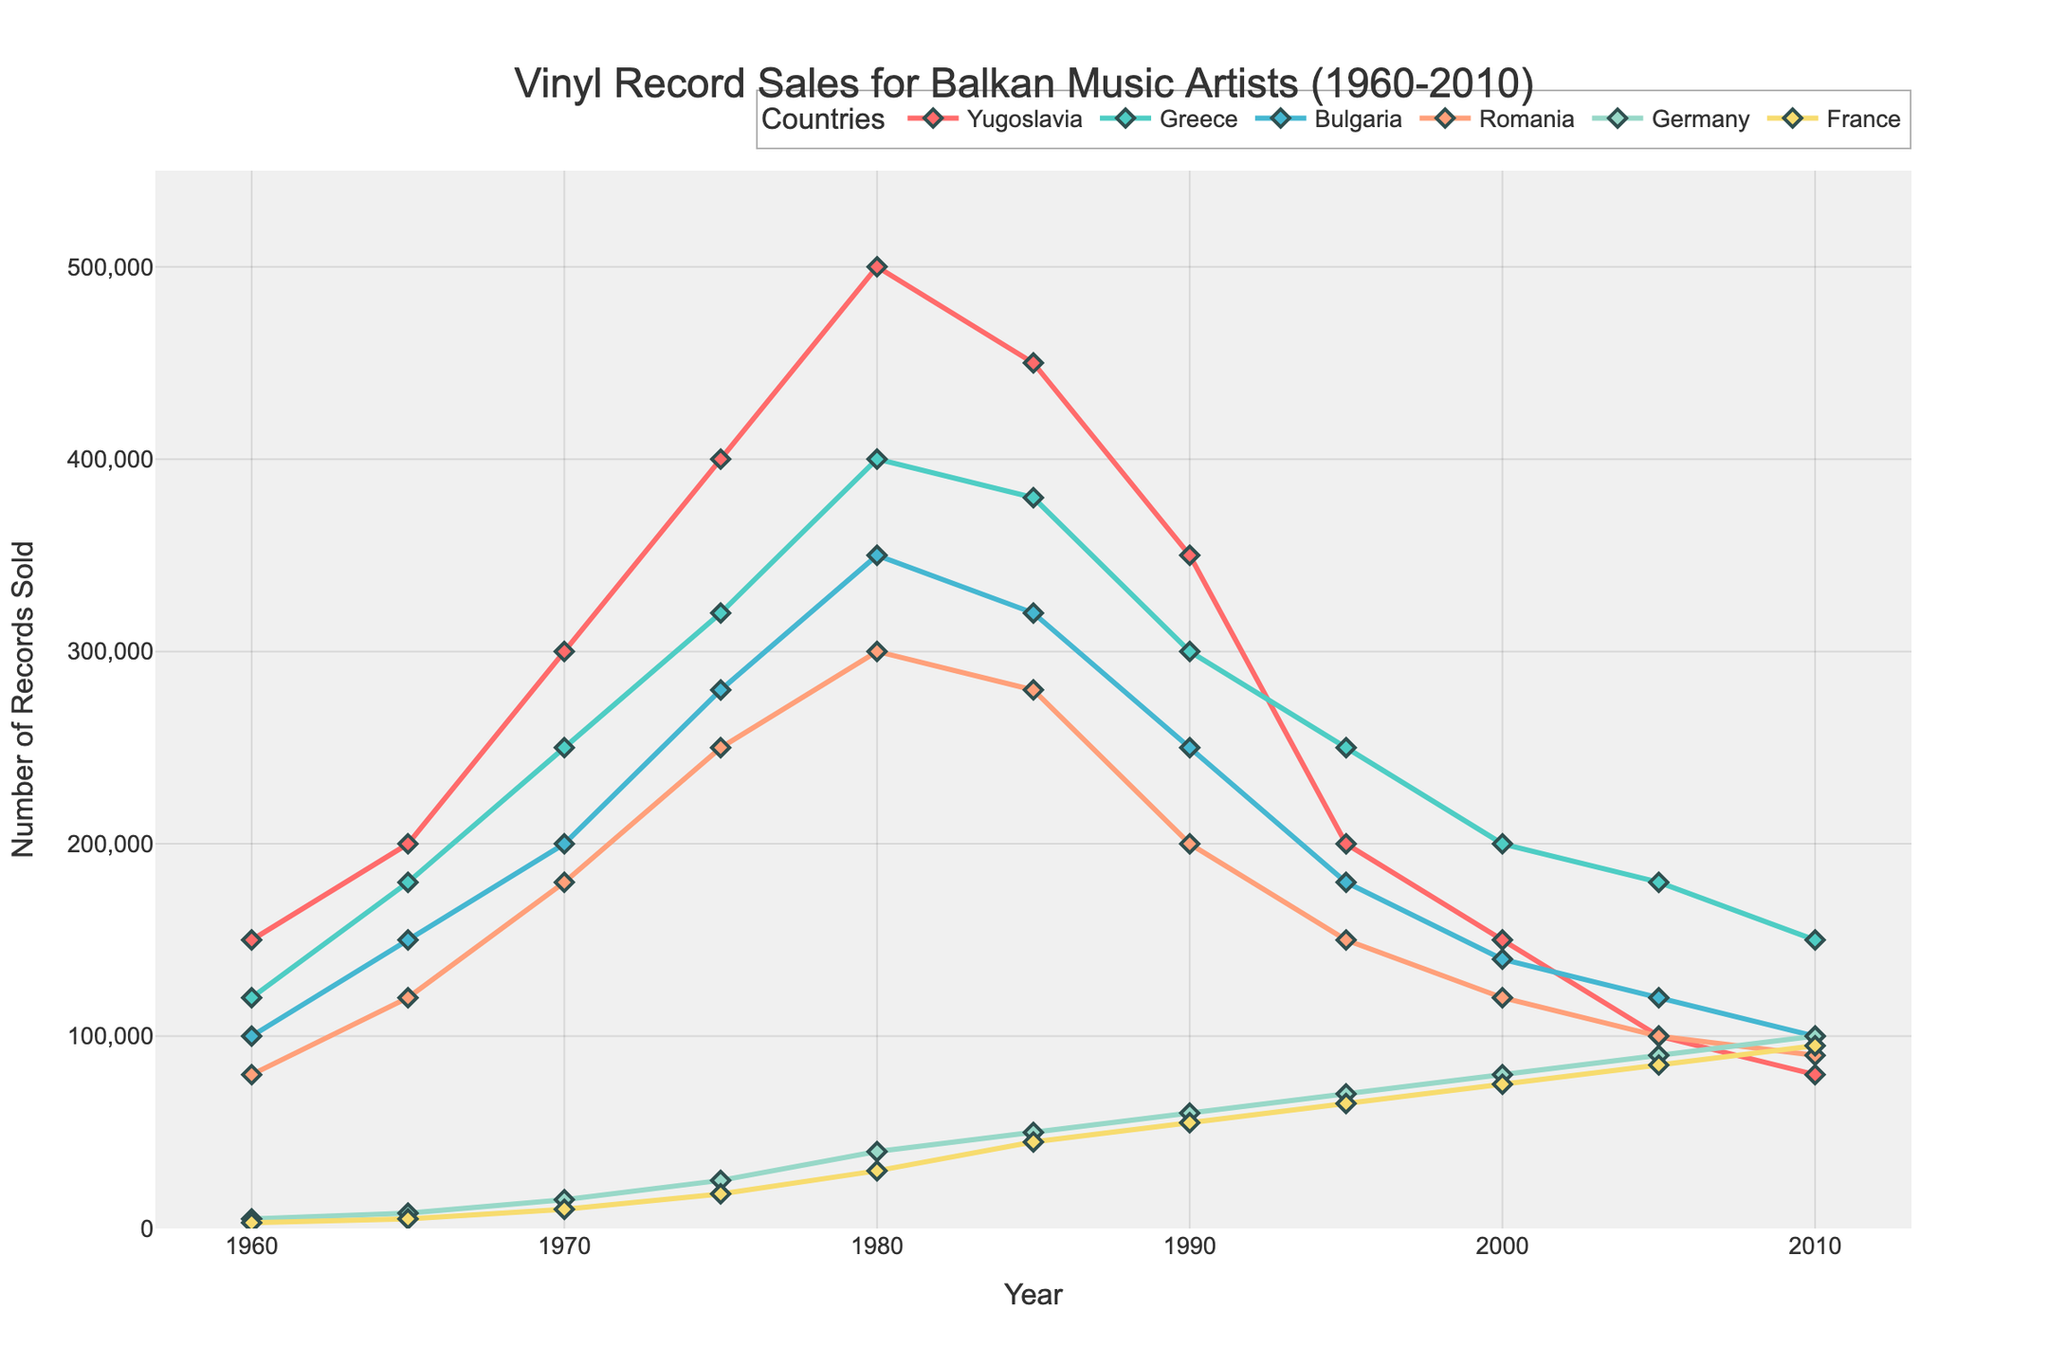What is the trend of vinyl record sales for Yugoslavia from 1960 to 2010? Yugoslavia's vinyl record sales show an initially increasing trend from 1960 (150,000) to 1980 (500,000), then a decline to 2010 (80,000).
Answer: Increasing then decreasing Which country had the highest vinyl record sales in 1980? In 1980, the highest record sales among the countries listed was in Yugoslavia with 500,000 records sold.
Answer: Yugoslavia How did the record sales in France change over the years? The record sales in France gradually increased from 3,000 in 1960 to 95,000 in 2010, showing a general upward trend.
Answer: Increased Which two countries had the most similar record sales in 2010? In 2010, Germany and France had similar record sales with 100,000 and 95,000 records sold, respectively.
Answer: Germany and France What is the average vinyl record sales in Romania from 1960 to 2010? The sales in Romania from 1960 to 2010 (80,000, 120,000, 180,000, 250,000, 300,000, 280,000, 200,000, 150,000, 120,000, 100,000, 90,000) sum to 1,870,000. There are 11 values, so the average is 1,870,000 / 11 ≈ 170,000.
Answer: 170,000 Which country's vinyl record sales decreased the most between 1980 and 1990? Yugoslavia's sales decreased from 500,000 in 1980 to 350,000 in 1990, a decrease of 150,000. Other countries had smaller decreases.
Answer: Yugoslavia Compare the sales growth rate between 1960 and 1970 for Greece and Bulgaria. Which country had a higher growth rate? Greece's sales grew from 120,000 in 1960 to 250,000 in 1970, an increase of 130,000 (108%). Bulgaria's sales grew from 100,000 to 200,000, an increase of 100,000 (100%). Therefore, Greece had a higher growth rate.
Answer: Greece Is there a pattern in the data that suggests when all six countries had increased record sales simultaneously? By visually inspecting the plot, all six countries show an increase simultaneously from 1960 to 1980.
Answer: 1960 to 1980 